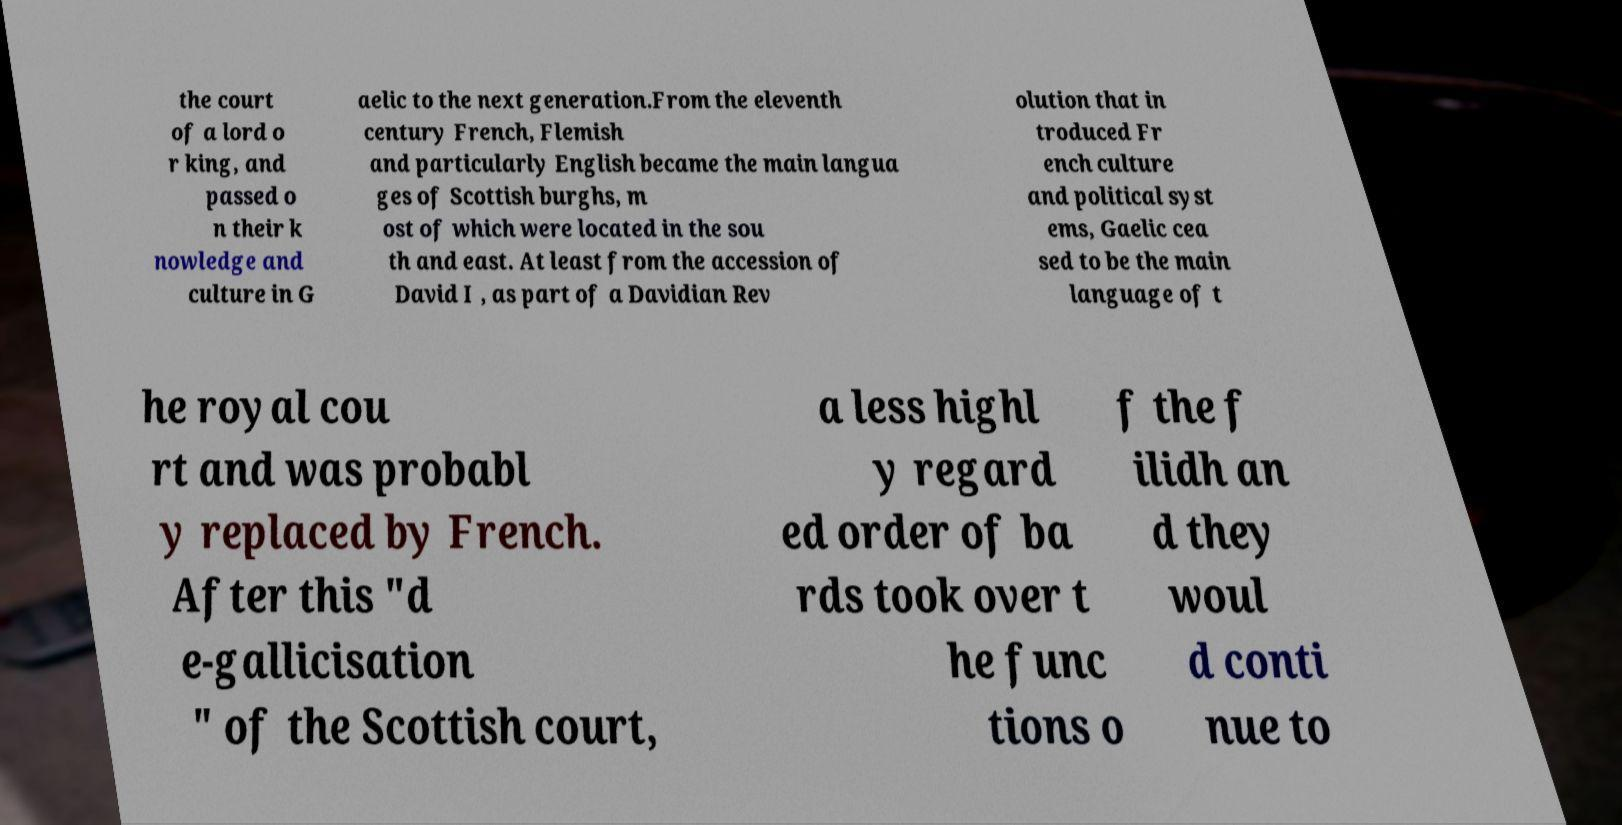I need the written content from this picture converted into text. Can you do that? the court of a lord o r king, and passed o n their k nowledge and culture in G aelic to the next generation.From the eleventh century French, Flemish and particularly English became the main langua ges of Scottish burghs, m ost of which were located in the sou th and east. At least from the accession of David I , as part of a Davidian Rev olution that in troduced Fr ench culture and political syst ems, Gaelic cea sed to be the main language of t he royal cou rt and was probabl y replaced by French. After this "d e-gallicisation " of the Scottish court, a less highl y regard ed order of ba rds took over t he func tions o f the f ilidh an d they woul d conti nue to 